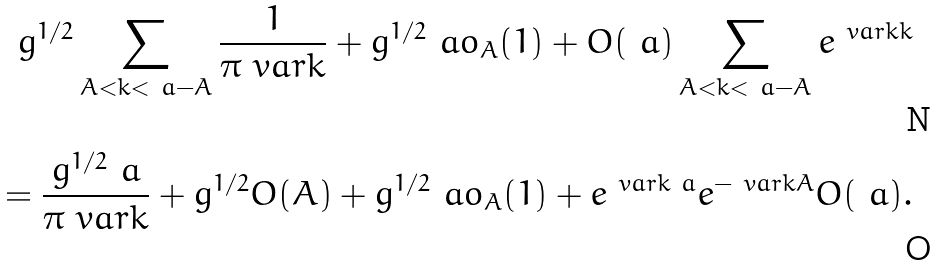Convert formula to latex. <formula><loc_0><loc_0><loc_500><loc_500>g ^ { 1 / 2 } \sum _ { A < k < \ a - A } \frac { 1 } { \pi \ v a r k } + g ^ { 1 / 2 } \ a o _ { A } ( 1 ) + O ( \ a ) \sum _ { A < k < \ a - A } e ^ { \ v a r k k } \\ = \frac { g ^ { 1 / 2 } \ a } { \pi \ v a r k } + g ^ { 1 / 2 } O ( A ) + g ^ { 1 / 2 } \ a o _ { A } ( 1 ) + e ^ { \ v a r k \ a } e ^ { - \ v a r k A } O ( \ a ) .</formula> 